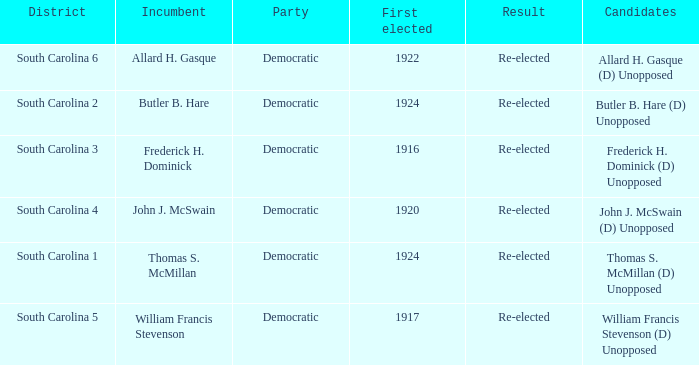What is the result for thomas s. mcmillan? Re-elected. 